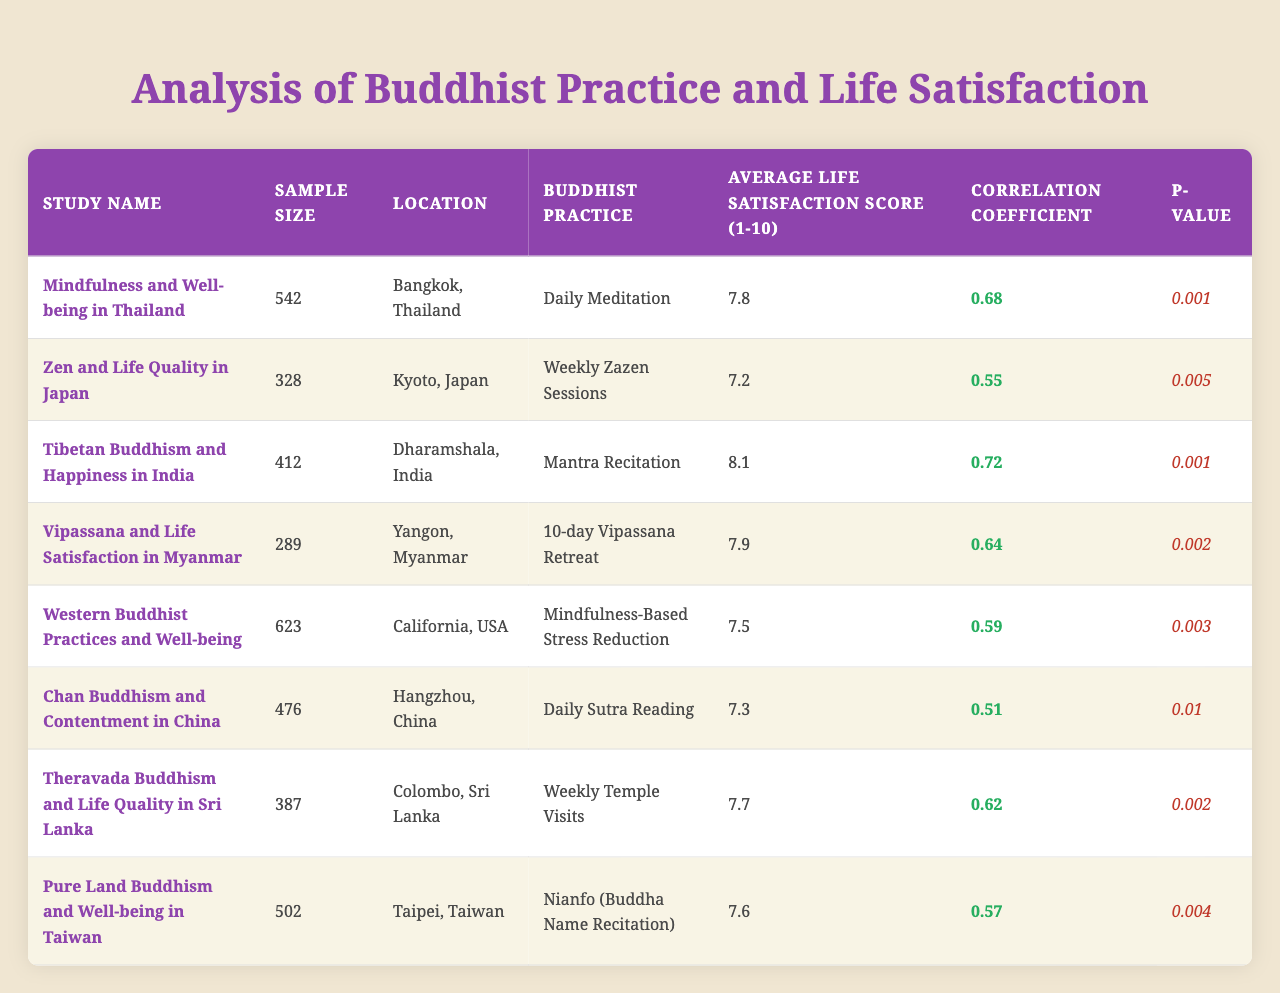What is the highest average life satisfaction score in the table? Looking through the "Average Life Satisfaction Score" column, the maximum score is 8.1 from the study titled "Tibetan Buddhism and Happiness in India."
Answer: 8.1 Which study reports the lowest correlation coefficient? By examining the "Correlation Coefficient" column, the lowest value is 0.51, which corresponds to the study "Chan Buddhism and Contentment in China."
Answer: 0.51 How many studies have a p-value less than 0.005? The p-values less than 0.005 can be identified by examining the "p-value" column. The studies with p-values 0.001 & 0.002 can be counted. There are four such studies: "Mindfulness and Well-being in Thailand," "Tibetan Buddhism and Happiness in India," "Vipassana and Life Satisfaction in Myanmar," and "Theravada Buddhism and Life Quality in Sri Lanka."
Answer: 4 Which types of Buddhist practices are included in the studies from locations of Thailand and Sri Lanka? The studies from Thailand and Sri Lanka are listed as "Daily Meditation" for Thailand and "Weekly Temple Visits" for Sri Lanka under the "Buddhist Practice" column.
Answer: Daily Meditation and Weekly Temple Visits What is the average life satisfaction score for studies with a correlation coefficient greater than 0.6? The studies with a correlation coefficient greater than 0.6 are "Mindfulness and Well-being in Thailand" (7.8), "Tibetan Buddhism and Happiness in India" (8.1), "Vipassana and Life Satisfaction in Myanmar" (7.9), and "Theravada Buddhism and Life Quality in Sri Lanka" (7.7). Summing the scores gives 31.5, and dividing by 4 gives an average of 31.5 / 4 = 7.875.
Answer: 7.875 Is the correlation coefficient for "Western Buddhist Practices and Well-being" above 0.5? The correlation coefficient for this study is 0.59, which is indeed above 0.5.
Answer: Yes What relationship can be drawn between meditation practices and reported life satisfaction scores based on the data? The studies indicating daily or intensive meditation practices such as "Daily Meditation" and "10-day Vipassana Retreat" show higher life satisfaction scores (7.8 and 7.9, respectively) compared to less frequent practices (e.g., "Weekly Zazen Sessions" at 7.2), suggesting that more frequent meditation could be correlated with higher life satisfaction.
Answer: Higher frequency may correlate with higher life satisfaction 